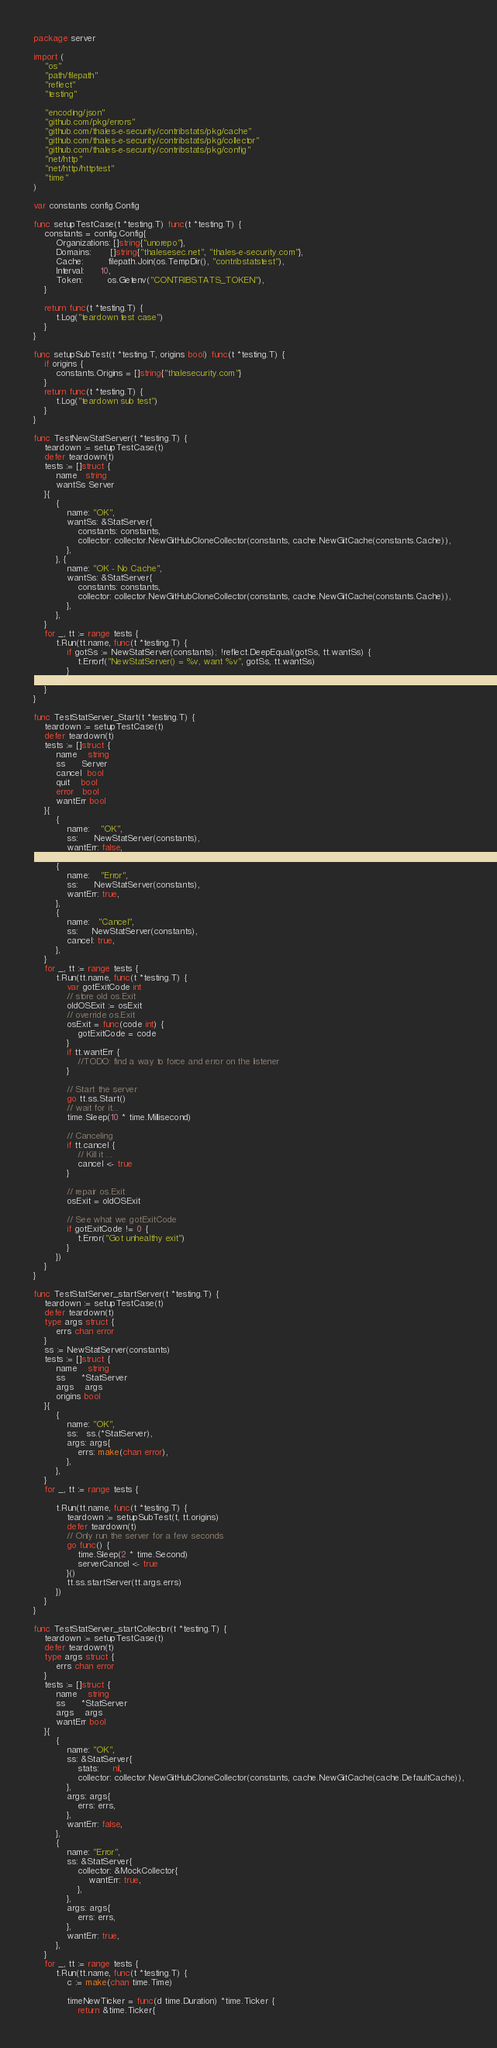Convert code to text. <code><loc_0><loc_0><loc_500><loc_500><_Go_>package server

import (
	"os"
	"path/filepath"
	"reflect"
	"testing"

	"encoding/json"
	"github.com/pkg/errors"
	"github.com/thales-e-security/contribstats/pkg/cache"
	"github.com/thales-e-security/contribstats/pkg/collector"
	"github.com/thales-e-security/contribstats/pkg/config"
	"net/http"
	"net/http/httptest"
	"time"
)

var constants config.Config

func setupTestCase(t *testing.T) func(t *testing.T) {
	constants = config.Config{
		Organizations: []string{"unorepo"},
		Domains:       []string{"thalesesec.net", "thales-e-security.com"},
		Cache:         filepath.Join(os.TempDir(), "contribstatstest"),
		Interval:      10,
		Token:         os.Getenv("CONTRIBSTATS_TOKEN"),
	}

	return func(t *testing.T) {
		t.Log("teardown test case")
	}
}

func setupSubTest(t *testing.T, origins bool) func(t *testing.T) {
	if origins {
		constants.Origins = []string{"thalesecurity.com"}
	}
	return func(t *testing.T) {
		t.Log("teardown sub test")
	}
}

func TestNewStatServer(t *testing.T) {
	teardown := setupTestCase(t)
	defer teardown(t)
	tests := []struct {
		name   string
		wantSs Server
	}{
		{
			name: "OK",
			wantSs: &StatServer{
				constants: constants,
				collector: collector.NewGitHubCloneCollector(constants, cache.NewGitCache(constants.Cache)),
			},
		}, {
			name: "OK - No Cache",
			wantSs: &StatServer{
				constants: constants,
				collector: collector.NewGitHubCloneCollector(constants, cache.NewGitCache(constants.Cache)),
			},
		},
	}
	for _, tt := range tests {
		t.Run(tt.name, func(t *testing.T) {
			if gotSs := NewStatServer(constants); !reflect.DeepEqual(gotSs, tt.wantSs) {
				t.Errorf("NewStatServer() = %v, want %v", gotSs, tt.wantSs)
			}
		})
	}
}

func TestStatServer_Start(t *testing.T) {
	teardown := setupTestCase(t)
	defer teardown(t)
	tests := []struct {
		name    string
		ss      Server
		cancel  bool
		quit    bool
		error   bool
		wantErr bool
	}{
		{
			name:    "OK",
			ss:      NewStatServer(constants),
			wantErr: false,
		},
		{
			name:    "Error",
			ss:      NewStatServer(constants),
			wantErr: true,
		},
		{
			name:   "Cancel",
			ss:     NewStatServer(constants),
			cancel: true,
		},
	}
	for _, tt := range tests {
		t.Run(tt.name, func(t *testing.T) {
			var gotExitCode int
			// store old os.Exit
			oldOSExit := osExit
			// override os.Exit
			osExit = func(code int) {
				gotExitCode = code
			}
			if tt.wantErr {
				//TODO: find a way to force and error on the listener
			}

			// Start the server
			go tt.ss.Start()
			// wait for it...
			time.Sleep(10 * time.Millisecond)

			// Canceling
			if tt.cancel {
				// Kill it ...
				cancel <- true
			}

			// repair os.Exit
			osExit = oldOSExit

			// See what we gotExitCode
			if gotExitCode != 0 {
				t.Error("Got unhealthy exit")
			}
		})
	}
}

func TestStatServer_startServer(t *testing.T) {
	teardown := setupTestCase(t)
	defer teardown(t)
	type args struct {
		errs chan error
	}
	ss := NewStatServer(constants)
	tests := []struct {
		name    string
		ss      *StatServer
		args    args
		origins bool
	}{
		{
			name: "OK",
			ss:   ss.(*StatServer),
			args: args{
				errs: make(chan error),
			},
		},
	}
	for _, tt := range tests {

		t.Run(tt.name, func(t *testing.T) {
			teardown := setupSubTest(t, tt.origins)
			defer teardown(t)
			// Only run the server for a few seconds
			go func() {
				time.Sleep(2 * time.Second)
				serverCancel <- true
			}()
			tt.ss.startServer(tt.args.errs)
		})
	}
}

func TestStatServer_startCollector(t *testing.T) {
	teardown := setupTestCase(t)
	defer teardown(t)
	type args struct {
		errs chan error
	}
	tests := []struct {
		name    string
		ss      *StatServer
		args    args
		wantErr bool
	}{
		{
			name: "OK",
			ss: &StatServer{
				stats:     nil,
				collector: collector.NewGitHubCloneCollector(constants, cache.NewGitCache(cache.DefaultCache)),
			},
			args: args{
				errs: errs,
			},
			wantErr: false,
		},
		{
			name: "Error",
			ss: &StatServer{
				collector: &MockCollector{
					wantErr: true,
				},
			},
			args: args{
				errs: errs,
			},
			wantErr: true,
		},
	}
	for _, tt := range tests {
		t.Run(tt.name, func(t *testing.T) {
			c := make(chan time.Time)

			timeNewTicker = func(d time.Duration) *time.Ticker {
				return &time.Ticker{</code> 